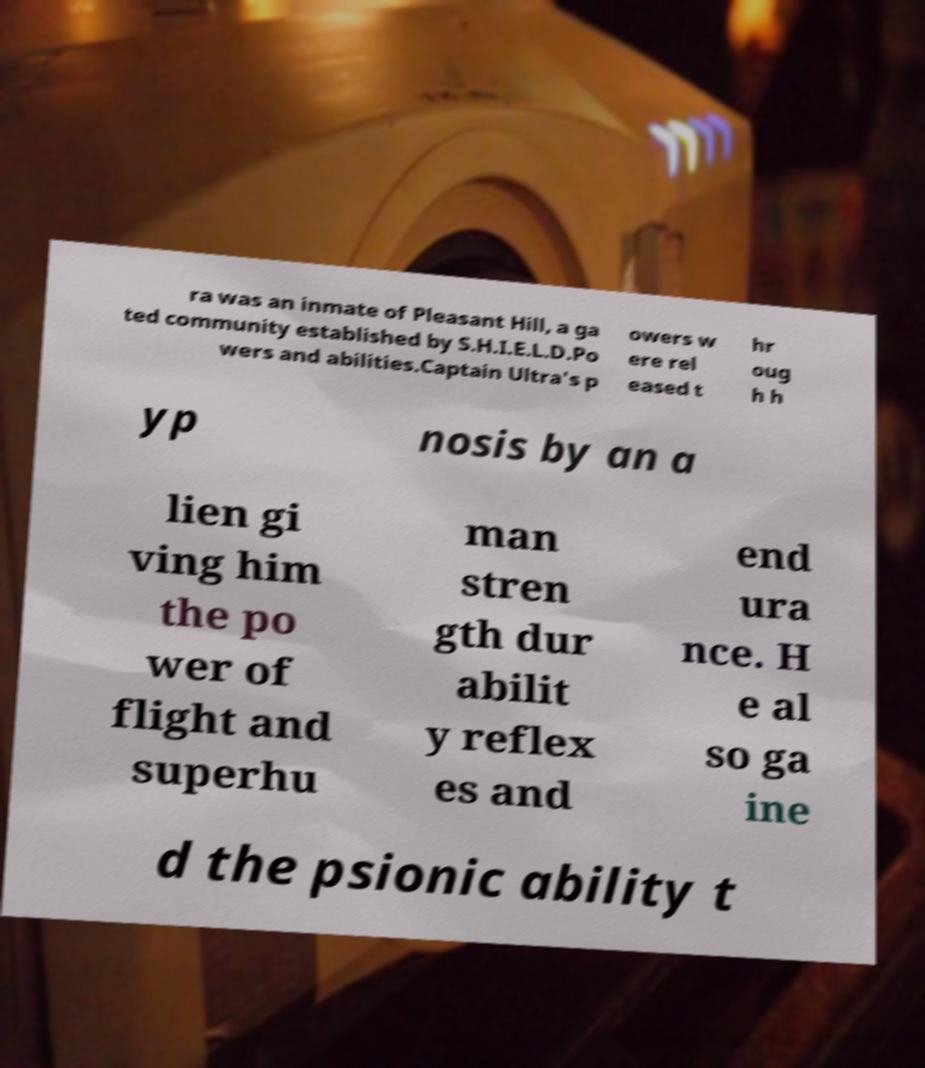Please identify and transcribe the text found in this image. ra was an inmate of Pleasant Hill, a ga ted community established by S.H.I.E.L.D.Po wers and abilities.Captain Ultra's p owers w ere rel eased t hr oug h h yp nosis by an a lien gi ving him the po wer of flight and superhu man stren gth dur abilit y reflex es and end ura nce. H e al so ga ine d the psionic ability t 